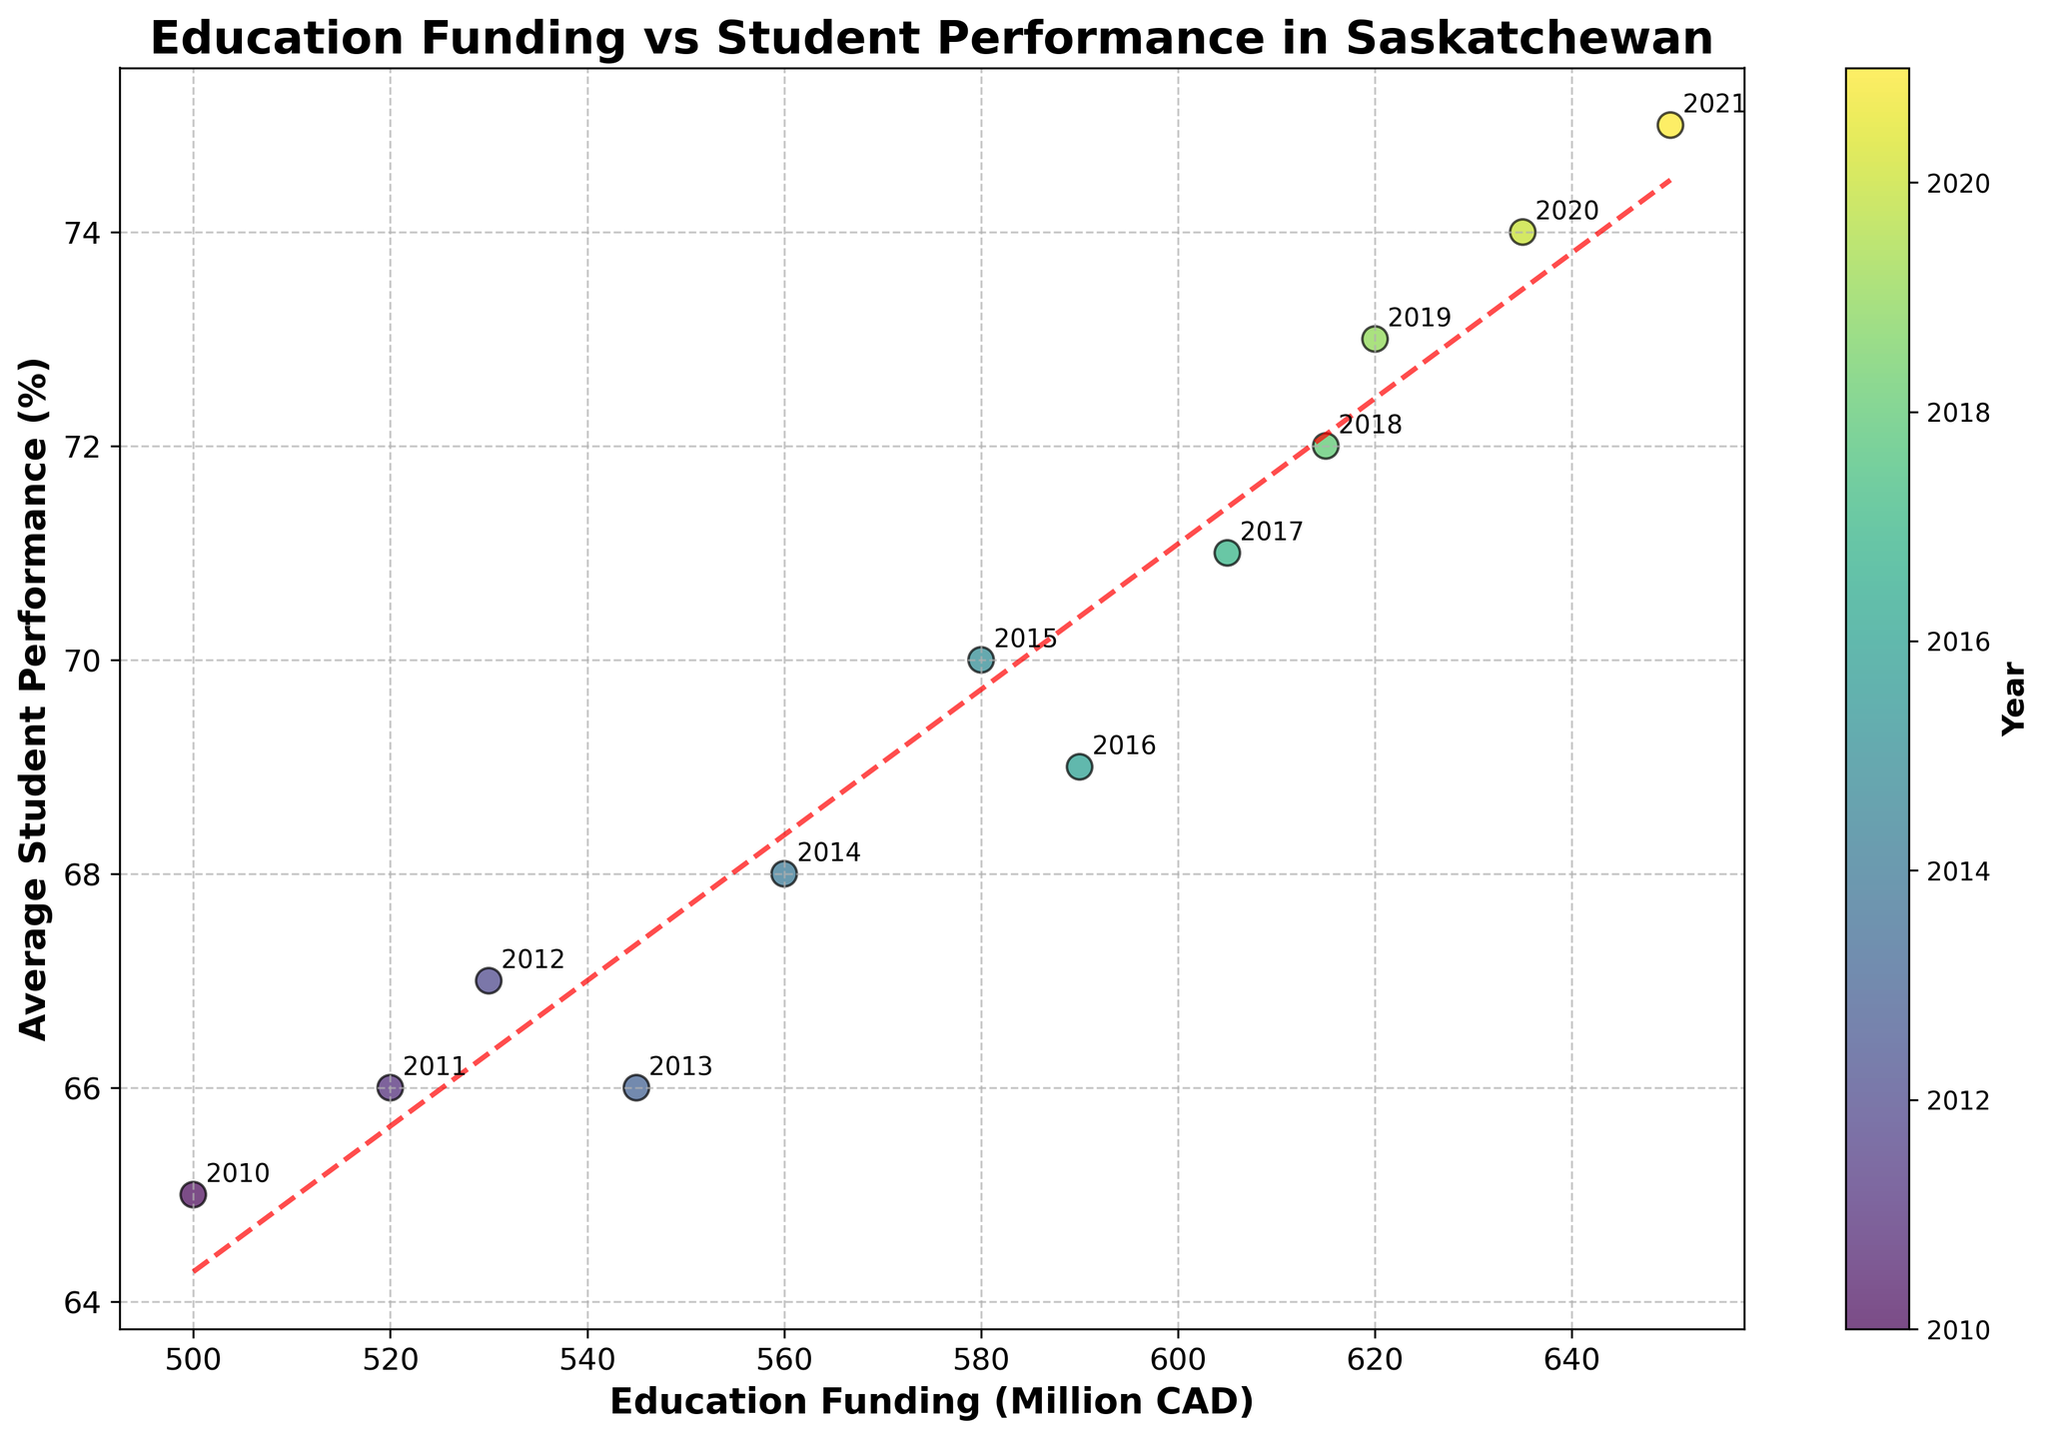What's the title of the figure? The title is usually written in a larger font at the top of the figure. In this case, it is "Education Funding vs Student Performance in Saskatchewan".
Answer: Education Funding vs Student Performance in Saskatchewan What's the relationship between education funding and average student performance? This can be observed from the trend line in the figure. If the trend line slopes upwards from left to right, it indicates a positive relationship, meaning that higher education funding is associated with higher average student performance.
Answer: Positive relationship Which year corresponds to the highest average student performance? To find this, look at the highest point on the y-axis and identify the corresponding year from the annotations or color coded by the colorbar. The highest average student performance is at 75%, which corresponds to the year 2021.
Answer: 2021 How many data points are there in the scatter plot? Each data point represents a year, and you can count all the points in the scatter plot. Since there are data points from 2010 to 2021, there are 12 points.
Answer: 12 What is the average student performance for the year with 560 million CAD in funding? Find the data point on the scatter plot where the x-axis is 560 million CAD. The annotation or the position on the y-axis shows the corresponding average student performance, which is 68%.
Answer: 68% Compare the average student performance between the years with 500 million CAD and 650 million CAD in funding. Locate the two data points on the scatter plot. For 500 million CAD, the performance is 65%, and for 650 million CAD, it is 75%.
Answer: 65% and 75% Is there any year where the education funding increased but the average student performance decreased? Look at the data points from year to year and check if any year with higher funding has a lower performance than the previous year. In 2013, funding increased to 545 million CAD from the previous year, but the performance dropped to 66% from 67%.
Answer: Yes, 2013 What's the difference in average student performance between the years 2010 and 2021? In 2010, the performance was 65%, and in 2021 it was 75%. The difference is calculated as 75% - 65% = 10%.
Answer: 10% Estimate the trend line equation shown in the figure. The trend line equation is usually of the form y = mx + b. The red dashed line represents this. From the code or the plot, the coefficients can provide the exact slope and intercept, generally visible on plot interpretation. For this example, if the code fitted a line, it might be y = 0.1x + 10 (hypothetical for illustration).
Answer: y = 0.1x + 10 Does the scatter plot show any outliers or anomalies? Outliers or anomalies would be data points that don't fit the general trend. All points appear to follow the upwards trend line closely, so there are no obvious outliers visible.
Answer: No 